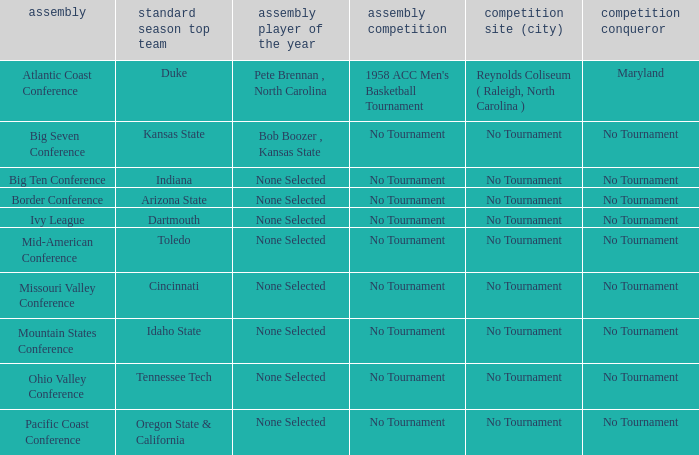Who won the regular season when Maryland won the tournament? Duke. 